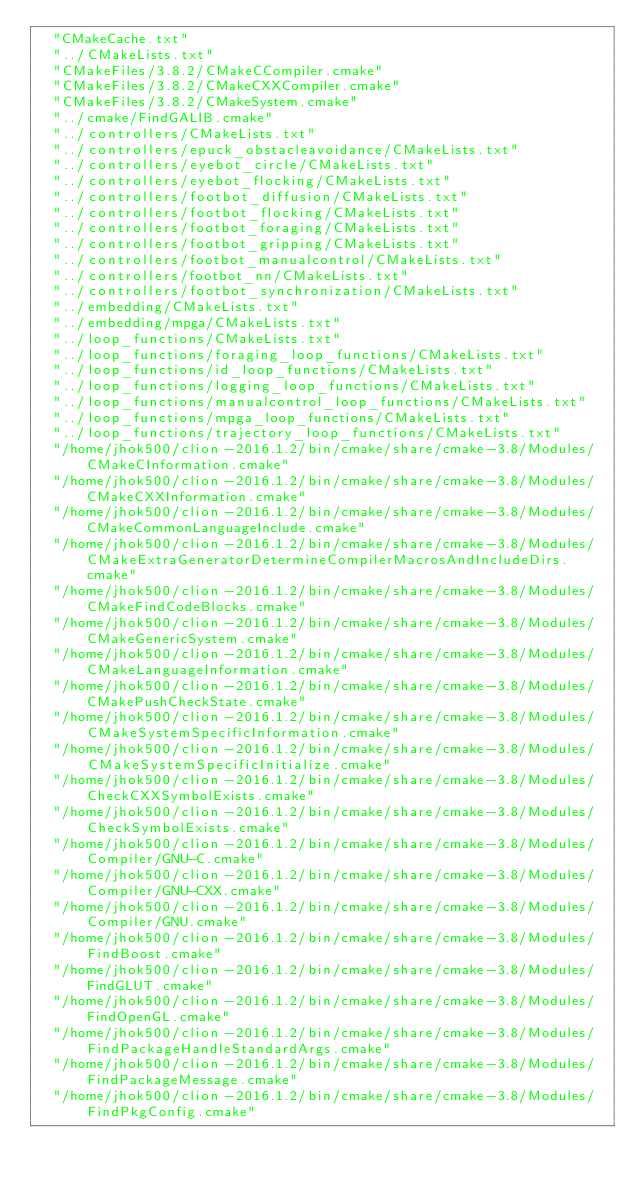Convert code to text. <code><loc_0><loc_0><loc_500><loc_500><_CMake_>  "CMakeCache.txt"
  "../CMakeLists.txt"
  "CMakeFiles/3.8.2/CMakeCCompiler.cmake"
  "CMakeFiles/3.8.2/CMakeCXXCompiler.cmake"
  "CMakeFiles/3.8.2/CMakeSystem.cmake"
  "../cmake/FindGALIB.cmake"
  "../controllers/CMakeLists.txt"
  "../controllers/epuck_obstacleavoidance/CMakeLists.txt"
  "../controllers/eyebot_circle/CMakeLists.txt"
  "../controllers/eyebot_flocking/CMakeLists.txt"
  "../controllers/footbot_diffusion/CMakeLists.txt"
  "../controllers/footbot_flocking/CMakeLists.txt"
  "../controllers/footbot_foraging/CMakeLists.txt"
  "../controllers/footbot_gripping/CMakeLists.txt"
  "../controllers/footbot_manualcontrol/CMakeLists.txt"
  "../controllers/footbot_nn/CMakeLists.txt"
  "../controllers/footbot_synchronization/CMakeLists.txt"
  "../embedding/CMakeLists.txt"
  "../embedding/mpga/CMakeLists.txt"
  "../loop_functions/CMakeLists.txt"
  "../loop_functions/foraging_loop_functions/CMakeLists.txt"
  "../loop_functions/id_loop_functions/CMakeLists.txt"
  "../loop_functions/logging_loop_functions/CMakeLists.txt"
  "../loop_functions/manualcontrol_loop_functions/CMakeLists.txt"
  "../loop_functions/mpga_loop_functions/CMakeLists.txt"
  "../loop_functions/trajectory_loop_functions/CMakeLists.txt"
  "/home/jhok500/clion-2016.1.2/bin/cmake/share/cmake-3.8/Modules/CMakeCInformation.cmake"
  "/home/jhok500/clion-2016.1.2/bin/cmake/share/cmake-3.8/Modules/CMakeCXXInformation.cmake"
  "/home/jhok500/clion-2016.1.2/bin/cmake/share/cmake-3.8/Modules/CMakeCommonLanguageInclude.cmake"
  "/home/jhok500/clion-2016.1.2/bin/cmake/share/cmake-3.8/Modules/CMakeExtraGeneratorDetermineCompilerMacrosAndIncludeDirs.cmake"
  "/home/jhok500/clion-2016.1.2/bin/cmake/share/cmake-3.8/Modules/CMakeFindCodeBlocks.cmake"
  "/home/jhok500/clion-2016.1.2/bin/cmake/share/cmake-3.8/Modules/CMakeGenericSystem.cmake"
  "/home/jhok500/clion-2016.1.2/bin/cmake/share/cmake-3.8/Modules/CMakeLanguageInformation.cmake"
  "/home/jhok500/clion-2016.1.2/bin/cmake/share/cmake-3.8/Modules/CMakePushCheckState.cmake"
  "/home/jhok500/clion-2016.1.2/bin/cmake/share/cmake-3.8/Modules/CMakeSystemSpecificInformation.cmake"
  "/home/jhok500/clion-2016.1.2/bin/cmake/share/cmake-3.8/Modules/CMakeSystemSpecificInitialize.cmake"
  "/home/jhok500/clion-2016.1.2/bin/cmake/share/cmake-3.8/Modules/CheckCXXSymbolExists.cmake"
  "/home/jhok500/clion-2016.1.2/bin/cmake/share/cmake-3.8/Modules/CheckSymbolExists.cmake"
  "/home/jhok500/clion-2016.1.2/bin/cmake/share/cmake-3.8/Modules/Compiler/GNU-C.cmake"
  "/home/jhok500/clion-2016.1.2/bin/cmake/share/cmake-3.8/Modules/Compiler/GNU-CXX.cmake"
  "/home/jhok500/clion-2016.1.2/bin/cmake/share/cmake-3.8/Modules/Compiler/GNU.cmake"
  "/home/jhok500/clion-2016.1.2/bin/cmake/share/cmake-3.8/Modules/FindBoost.cmake"
  "/home/jhok500/clion-2016.1.2/bin/cmake/share/cmake-3.8/Modules/FindGLUT.cmake"
  "/home/jhok500/clion-2016.1.2/bin/cmake/share/cmake-3.8/Modules/FindOpenGL.cmake"
  "/home/jhok500/clion-2016.1.2/bin/cmake/share/cmake-3.8/Modules/FindPackageHandleStandardArgs.cmake"
  "/home/jhok500/clion-2016.1.2/bin/cmake/share/cmake-3.8/Modules/FindPackageMessage.cmake"
  "/home/jhok500/clion-2016.1.2/bin/cmake/share/cmake-3.8/Modules/FindPkgConfig.cmake"</code> 